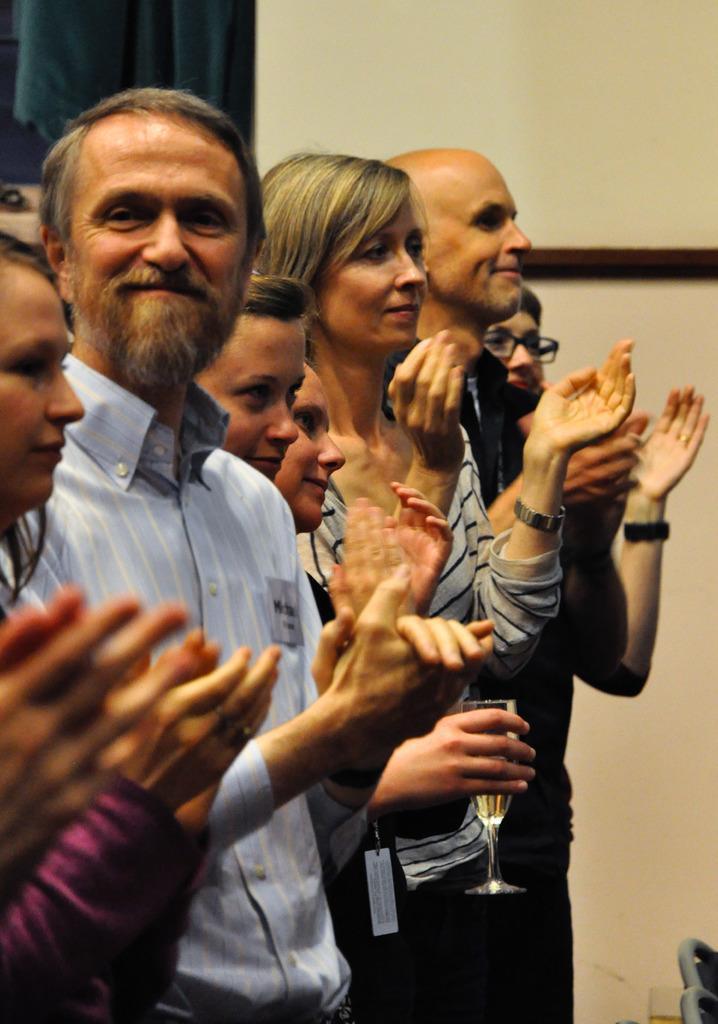How would you summarize this image in a sentence or two? In this image we can see few people standing and clapping their hands and a person is holding a glass and there is a curtain and a wall in the background. 